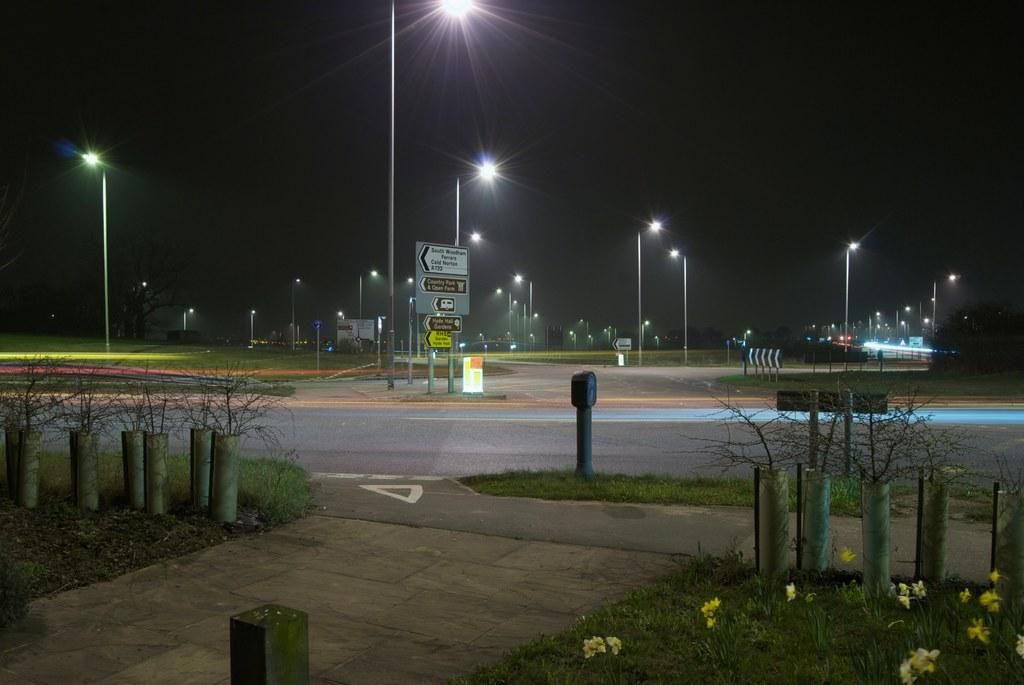What can be seen on the poles in the image? There are lights and boards with text on the poles in the image. What is visible in the foreground of the image? There is grass and plants in the foreground of the image. What else can be seen in the foreground of the image? There are poles in the foreground of the image. How would you describe the lighting in the top part of the image? The top part of the image is dark. How does the growth of the plants affect the experience of the person in the image? There is no person present in the image, so it is not possible to determine how the growth of the plants affects their experience. 